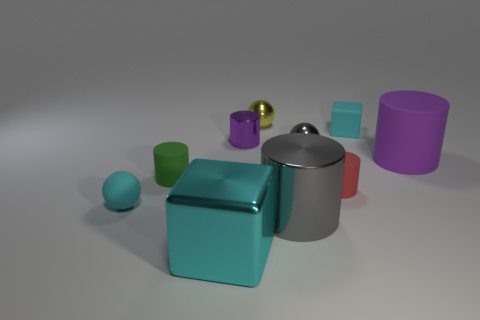Subtract all rubber spheres. How many spheres are left? 2 Subtract all yellow spheres. How many spheres are left? 2 Subtract all blocks. How many objects are left? 8 Subtract 2 cylinders. How many cylinders are left? 3 Subtract 1 gray cylinders. How many objects are left? 9 Subtract all cyan balls. Subtract all cyan blocks. How many balls are left? 2 Subtract all gray cubes. How many purple cylinders are left? 2 Subtract all tiny cyan metal balls. Subtract all tiny green cylinders. How many objects are left? 9 Add 2 small yellow shiny spheres. How many small yellow shiny spheres are left? 3 Add 4 small yellow objects. How many small yellow objects exist? 5 